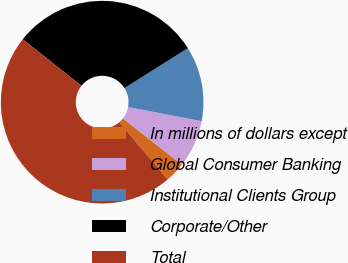Convert chart to OTSL. <chart><loc_0><loc_0><loc_500><loc_500><pie_chart><fcel>In millions of dollars except<fcel>Global Consumer Banking<fcel>Institutional Clients Group<fcel>Corporate/Other<fcel>Total<nl><fcel>3.22%<fcel>7.58%<fcel>11.95%<fcel>30.39%<fcel>46.86%<nl></chart> 